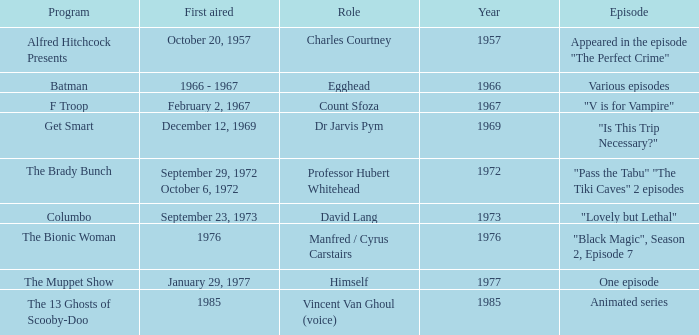What's the episode of Batman? Various episodes. 